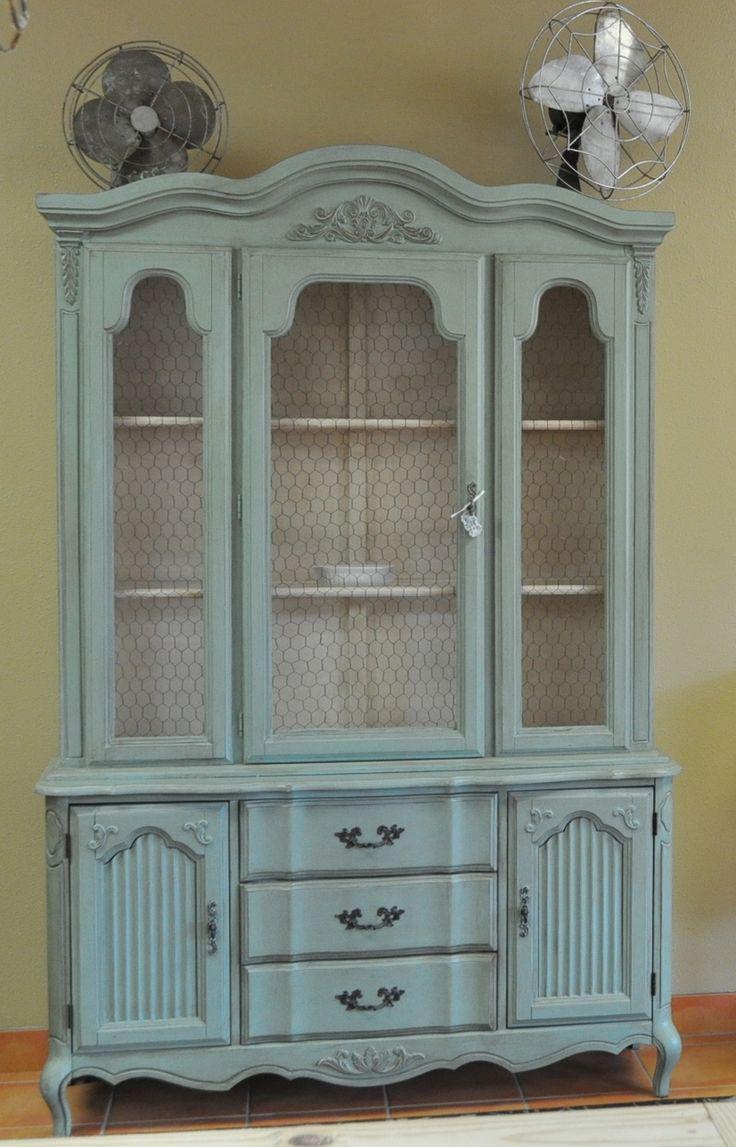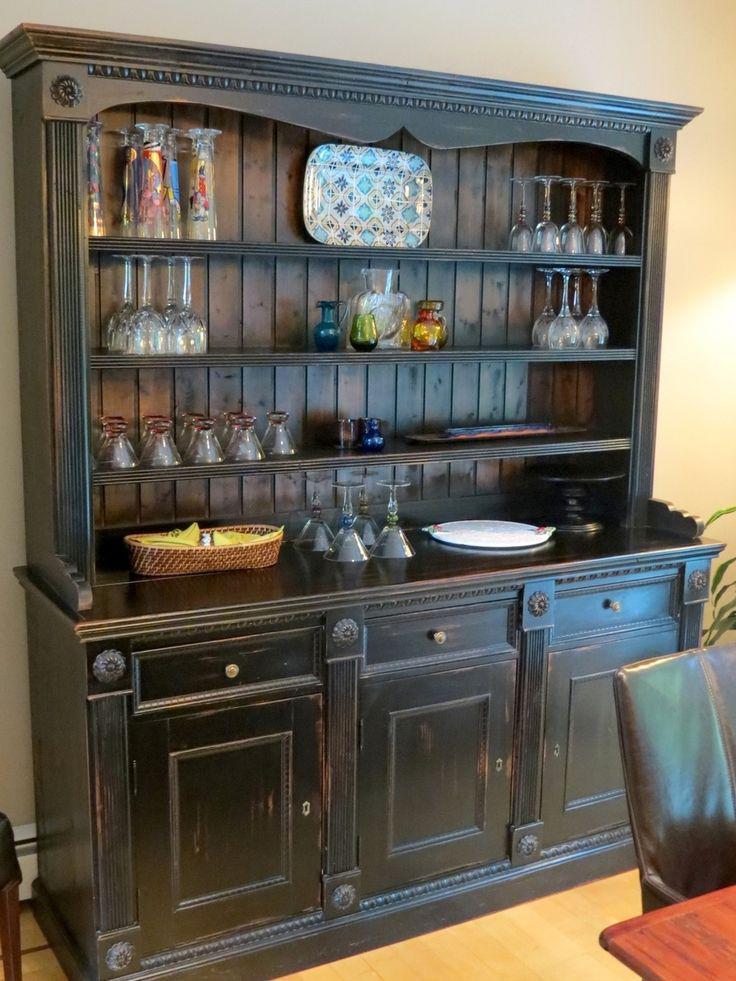The first image is the image on the left, the second image is the image on the right. Given the left and right images, does the statement "One of the cabinets has a curving arched solid-wood top." hold true? Answer yes or no. Yes. 